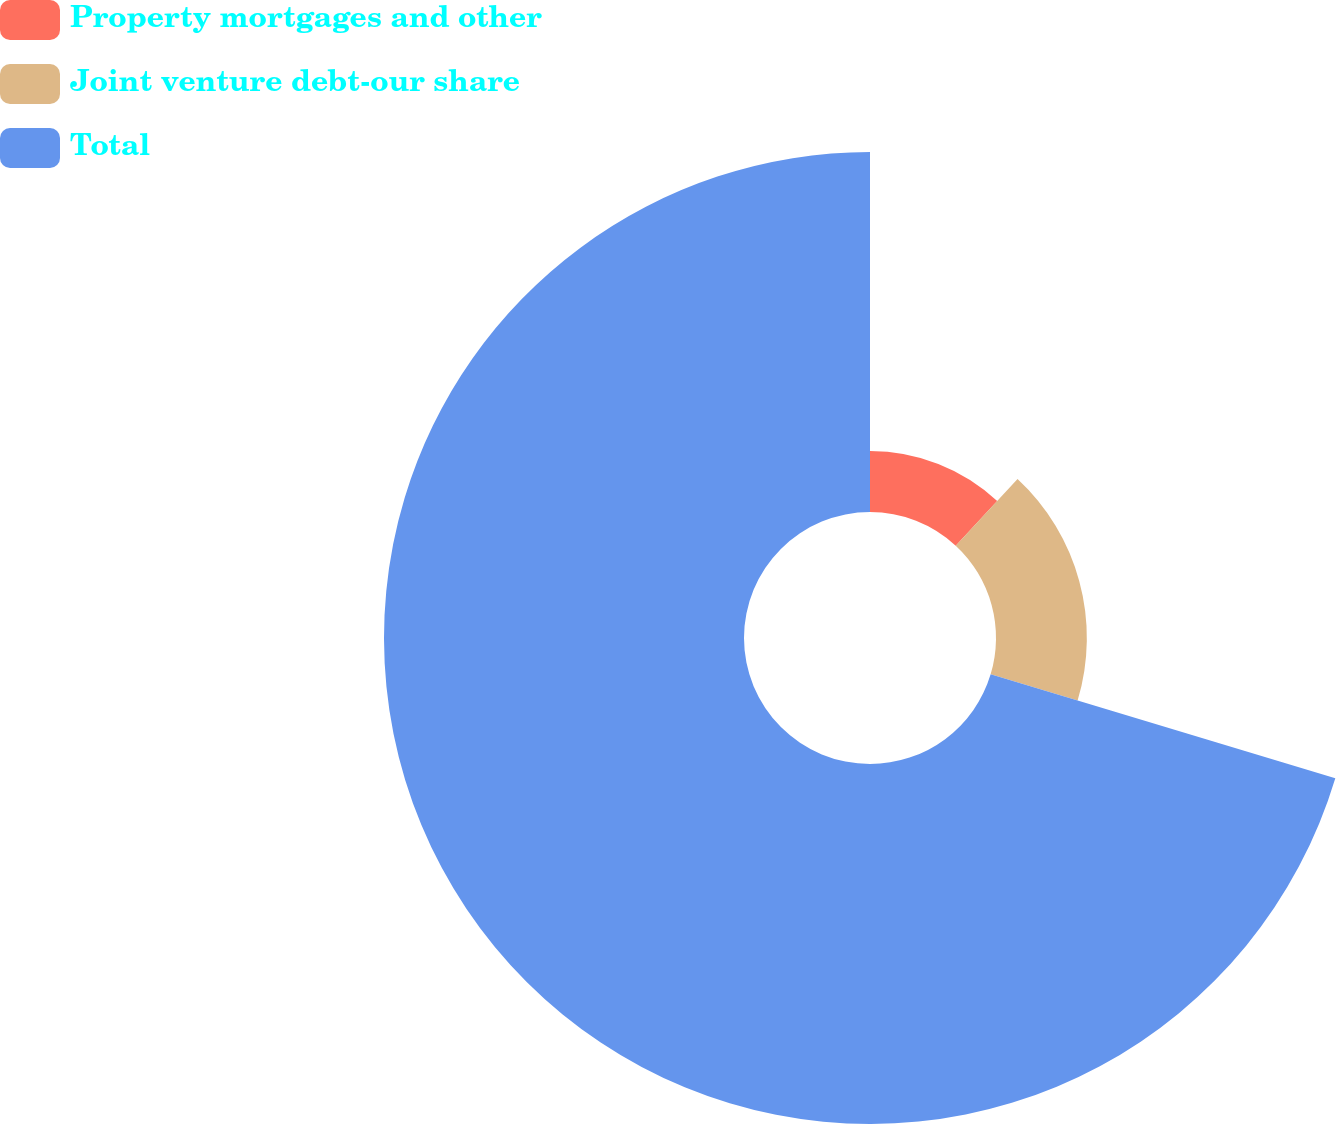Convert chart to OTSL. <chart><loc_0><loc_0><loc_500><loc_500><pie_chart><fcel>Property mortgages and other<fcel>Joint venture debt-our share<fcel>Total<nl><fcel>11.91%<fcel>17.75%<fcel>70.34%<nl></chart> 